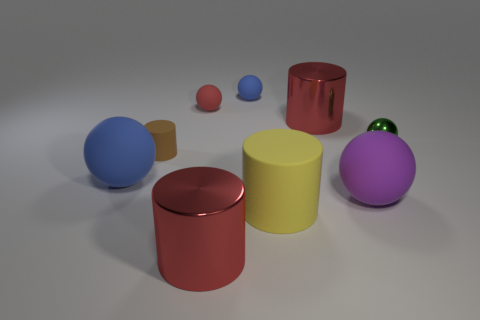Are there any other large things of the same shape as the green metal thing?
Make the answer very short. Yes. How many matte things are either blue objects or green spheres?
Offer a terse response. 2. The red rubber object is what shape?
Provide a short and direct response. Sphere. How many cyan objects have the same material as the large blue sphere?
Your response must be concise. 0. What is the color of the other cylinder that is the same material as the yellow cylinder?
Your answer should be very brief. Brown. Do the blue rubber sphere behind the green metallic thing and the purple thing have the same size?
Offer a very short reply. No. There is another matte thing that is the same shape as the large yellow rubber object; what is its color?
Ensure brevity in your answer.  Brown. There is a blue object in front of the large red cylinder that is behind the large red thing to the left of the yellow rubber thing; what shape is it?
Offer a terse response. Sphere. Does the brown matte object have the same shape as the large blue rubber object?
Offer a terse response. No. The yellow object that is in front of the brown thing that is behind the big blue ball is what shape?
Ensure brevity in your answer.  Cylinder. 